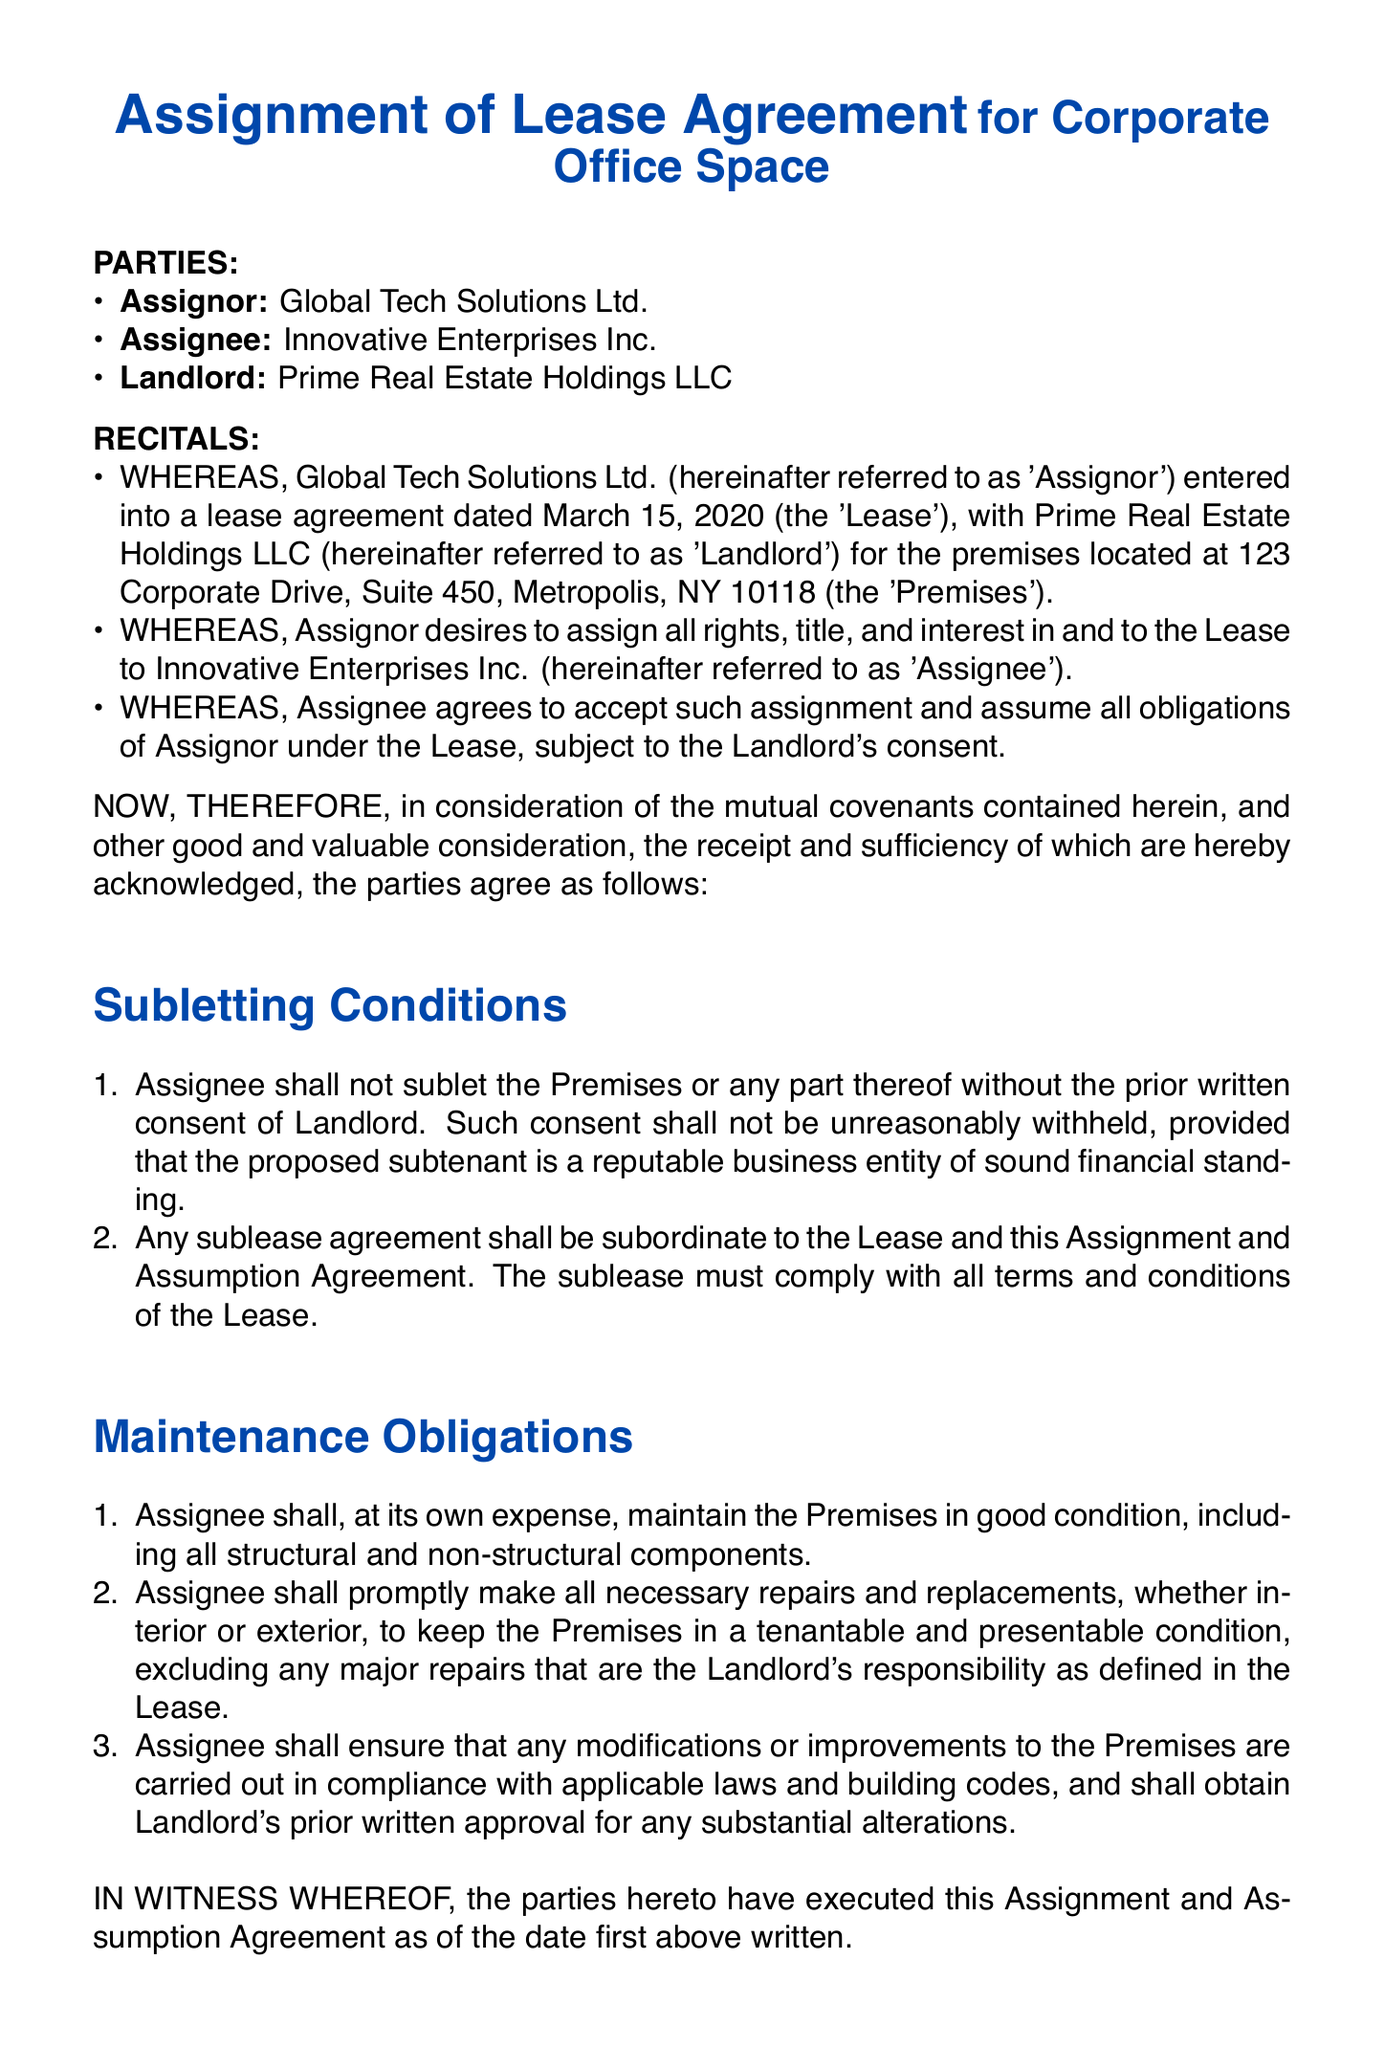What is the name of the Assignor? The Assignor is identified as Global Tech Solutions Ltd. in the document.
Answer: Global Tech Solutions Ltd What is the address of the Premises? The document specifies the address as 123 Corporate Drive, Suite 450, Metropolis, NY 10118.
Answer: 123 Corporate Drive, Suite 450, Metropolis, NY 10118 When was the original Lease agreement dated? The original Lease agreement is dated March 15, 2020, as stated in the recitals section of the document.
Answer: March 15, 2020 Can the Assignee sublet the Premises? Yes, the Assignee can sublet the Premises but requires prior written consent from the Landlord.
Answer: Yes, with consent What are the Assignee's obligations regarding maintenance? The Assignee must maintain the Premises in good condition and make necessary repairs at their own expense.
Answer: Maintain in good condition Who has to approve substantial alterations to the Premises? Any substantial alterations to the Premises require prior written approval from the Landlord.
Answer: The Landlord What must a subtenant be in terms of reputation? The proposed subtenant must be a reputable business entity of sound financial standing as per the subletting conditions.
Answer: Reputable business entity What is the status of any sublease agreement in relation to the Lease? Any sublease agreement shall be subordinate to the Lease and the Assignment and Assumption Agreement.
Answer: Subordinate to the Lease 